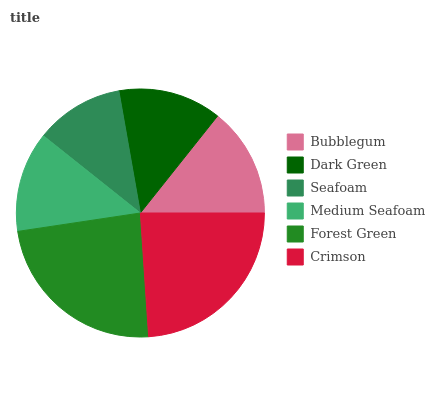Is Seafoam the minimum?
Answer yes or no. Yes. Is Crimson the maximum?
Answer yes or no. Yes. Is Dark Green the minimum?
Answer yes or no. No. Is Dark Green the maximum?
Answer yes or no. No. Is Bubblegum greater than Dark Green?
Answer yes or no. Yes. Is Dark Green less than Bubblegum?
Answer yes or no. Yes. Is Dark Green greater than Bubblegum?
Answer yes or no. No. Is Bubblegum less than Dark Green?
Answer yes or no. No. Is Bubblegum the high median?
Answer yes or no. Yes. Is Dark Green the low median?
Answer yes or no. Yes. Is Crimson the high median?
Answer yes or no. No. Is Medium Seafoam the low median?
Answer yes or no. No. 